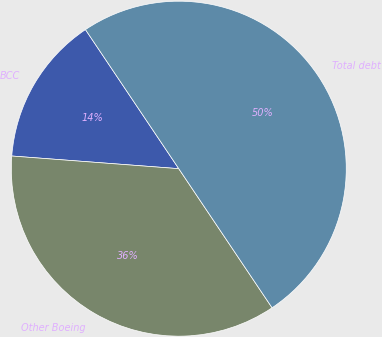Convert chart. <chart><loc_0><loc_0><loc_500><loc_500><pie_chart><fcel>BCC<fcel>Other Boeing<fcel>Total debt<nl><fcel>14.39%<fcel>35.61%<fcel>50.0%<nl></chart> 